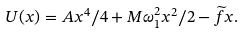Convert formula to latex. <formula><loc_0><loc_0><loc_500><loc_500>U ( x ) = A x ^ { 4 } / 4 + M \omega _ { 1 } ^ { 2 } x ^ { 2 } / 2 - \widetilde { f } x .</formula> 